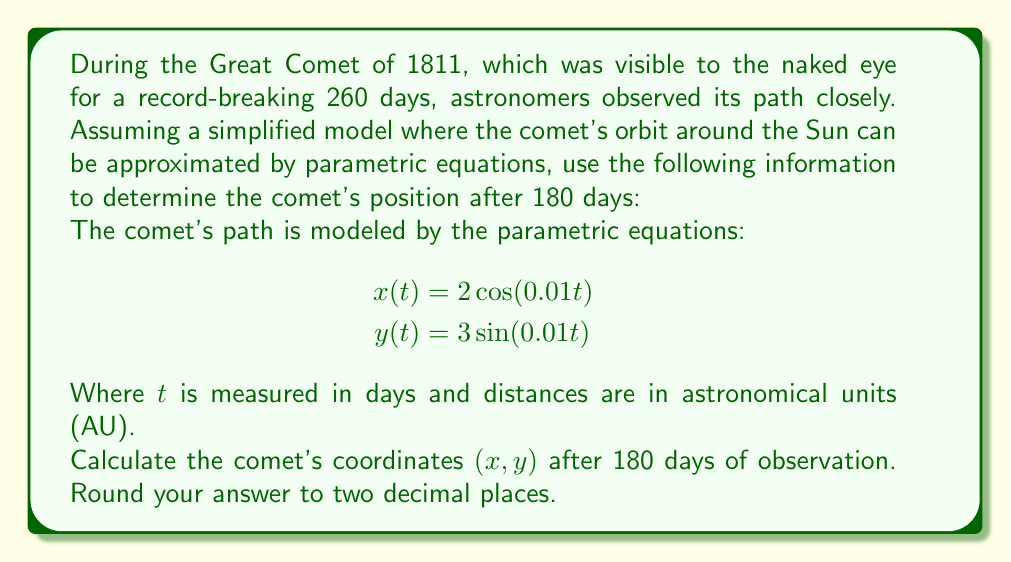Teach me how to tackle this problem. To solve this problem, we need to follow these steps:

1) We are given the parametric equations:
   $$x(t) = 2\cos(0.01t)$$
   $$y(t) = 3\sin(0.01t)$$

2) We need to find the position after 180 days, so we substitute $t = 180$ into both equations:

   For $x(180)$:
   $$x(180) = 2\cos(0.01 \cdot 180)$$
   $$x(180) = 2\cos(1.8)$$

   For $y(180)$:
   $$y(180) = 3\sin(0.01 \cdot 180)$$
   $$y(180) = 3\sin(1.8)$$

3) Now we need to calculate these values:

   $$\cos(1.8) \approx -0.2272$$
   $$\sin(1.8) \approx 0.9738$$

4) Multiplying by the coefficients:

   $$x(180) = 2 \cdot (-0.2272) \approx -0.4544$$
   $$y(180) = 3 \cdot 0.9738 \approx 2.9214$$

5) Rounding to two decimal places:

   $$x(180) \approx -0.45$$
   $$y(180) \approx 2.92$$

Therefore, after 180 days, the comet's position is approximately (-0.45 AU, 2.92 AU).
Answer: (-0.45, 2.92) 